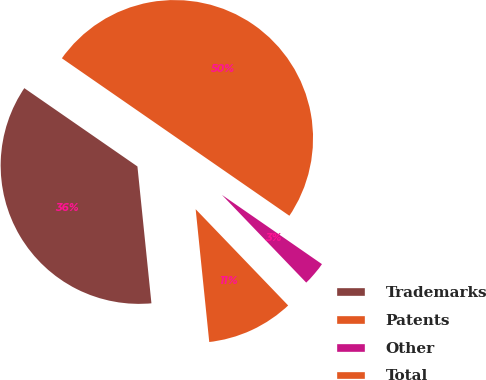Convert chart to OTSL. <chart><loc_0><loc_0><loc_500><loc_500><pie_chart><fcel>Trademarks<fcel>Patents<fcel>Other<fcel>Total<nl><fcel>36.26%<fcel>10.56%<fcel>3.18%<fcel>50.0%<nl></chart> 